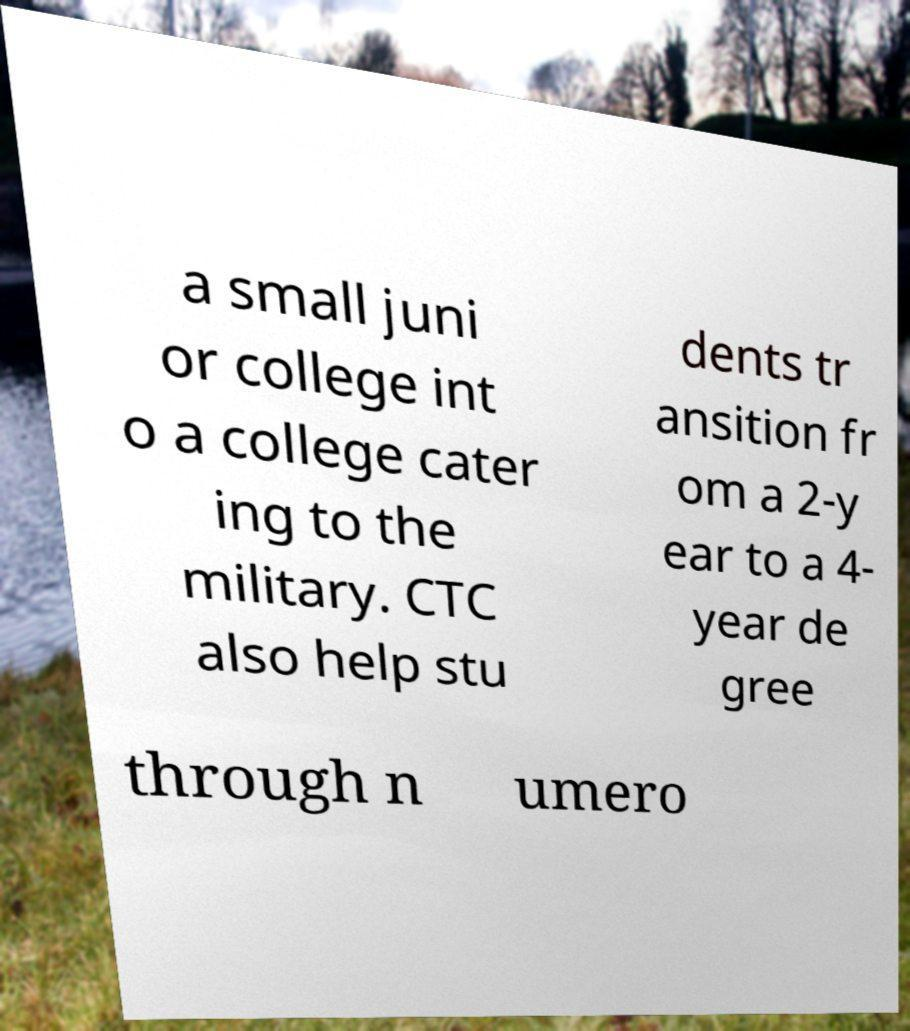Can you accurately transcribe the text from the provided image for me? a small juni or college int o a college cater ing to the military. CTC also help stu dents tr ansition fr om a 2-y ear to a 4- year de gree through n umero 